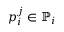Convert formula to latex. <formula><loc_0><loc_0><loc_500><loc_500>p _ { i } ^ { j } \in \mathbb { P } _ { i }</formula> 